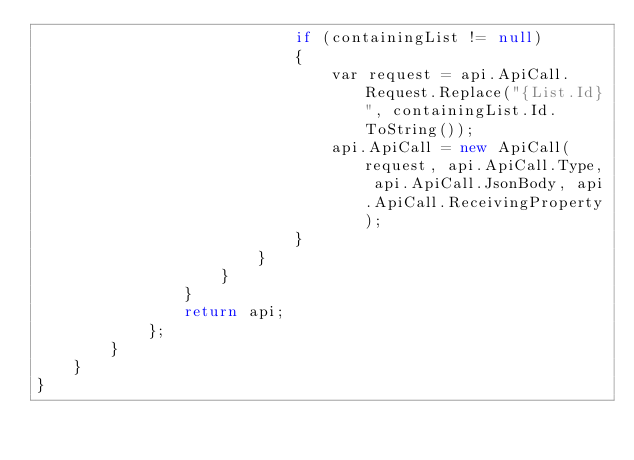Convert code to text. <code><loc_0><loc_0><loc_500><loc_500><_C#_>                            if (containingList != null)
                            {
                                var request = api.ApiCall.Request.Replace("{List.Id}", containingList.Id.ToString());
                                api.ApiCall = new ApiCall(request, api.ApiCall.Type, api.ApiCall.JsonBody, api.ApiCall.ReceivingProperty);
                            }
                        }
                    }
                }
                return api;
            };
        }
    }
}
</code> 